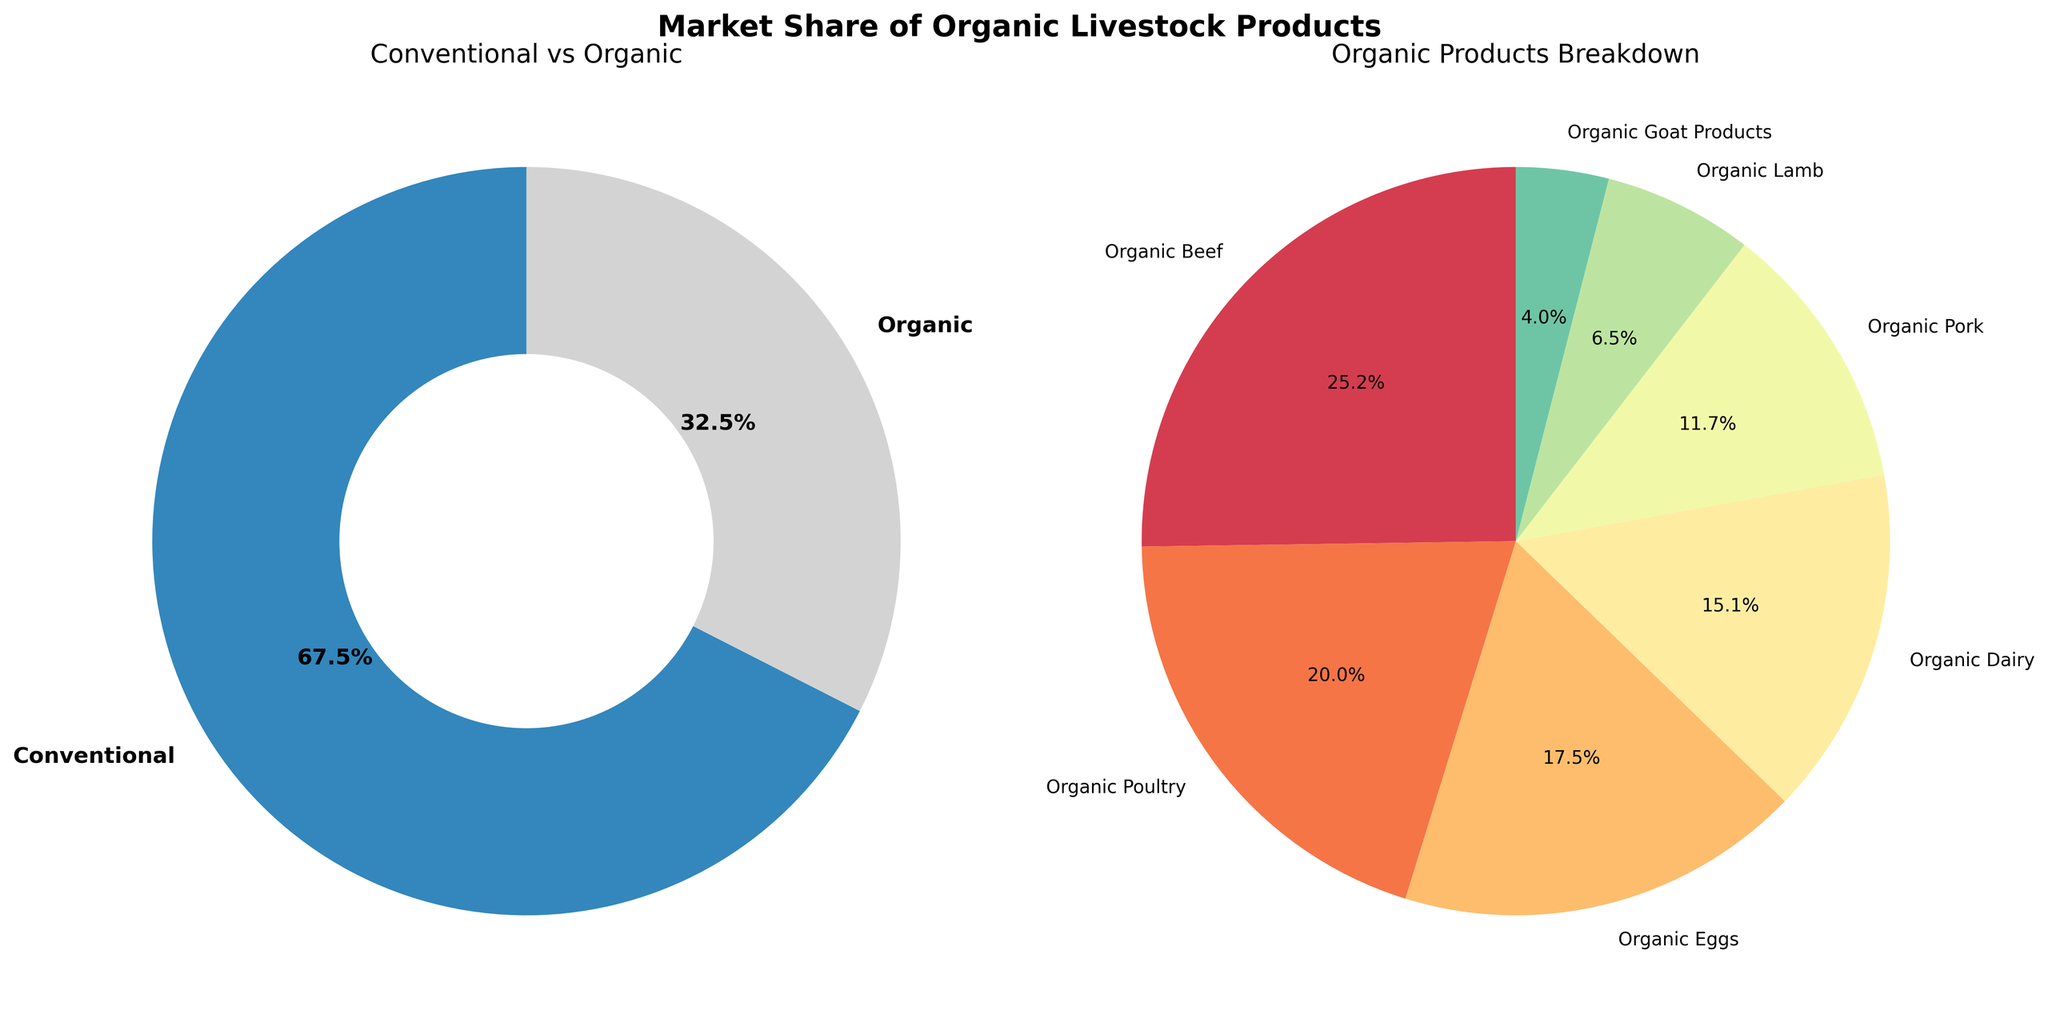What is the market share of conventional livestock products? The "Conventional vs Organic" pie chart shows that Conventional livestock products account for 67.5% of the market share.
Answer: 67.5% Which organic product has the highest market share? The "Organic Products Breakdown" pie chart shows market shares for different organic products, and Organic Beef has the highest share at 8.2%.
Answer: Organic Beef How much more market share does Organic Beef have compared to Organic Pork? From the "Organic Products Breakdown" pie chart, Organic Beef has a market share of 8.2%, and Organic Pork has 3.8%. The difference is calculated as 8.2% - 3.8% = 4.4%.
Answer: 4.4% What is the combined market share of Organic Poultry and Organic Eggs? From the "Organic Products Breakdown" pie chart, Organic Poultry has a market share of 6.5%, and Organic Eggs have 5.7%. The combined share is calculated as 6.5% + 5.7% = 12.2%.
Answer: 12.2% Which organic product has the lowest market share? The "Organic Products Breakdown" pie chart shows various organic products with their market shares, and Organic Goat Products has the lowest share at 1.3%.
Answer: Organic Goat Products Is the market share of Organic Dairy greater than that of Organic Pork? According to the "Organic Products Breakdown" pie chart, Organic Dairy has a market share of 4.9%, and Organic Pork has 3.8%. Since 4.9% is greater than 3.8%, Organic Dairy has a greater market share.
Answer: Yes Which product shares a similar market share to Organic Dairy? The "Organic Products Breakdown" pie chart indicates that Organic Eggs have a market share of 5.7%, which is relatively close to Organic Dairy's 4.9%.
Answer: Organic Eggs What is the difference in market share between Organic Lamb and Organic Goat Products? From the "Organic Products Breakdown" pie chart, Organic Lamb has a market share of 2.1%, and Organic Goat Products has 1.3%. The difference is calculated as 2.1% - 1.3% = 0.8%.
Answer: 0.8% How much total market share is occupied by all organic products combined? The "Conventional vs Organic" pie chart shows Organic products account for a total of 100% - 67.5% (conventional share) = 32.5% of the market.
Answer: 32.5% 